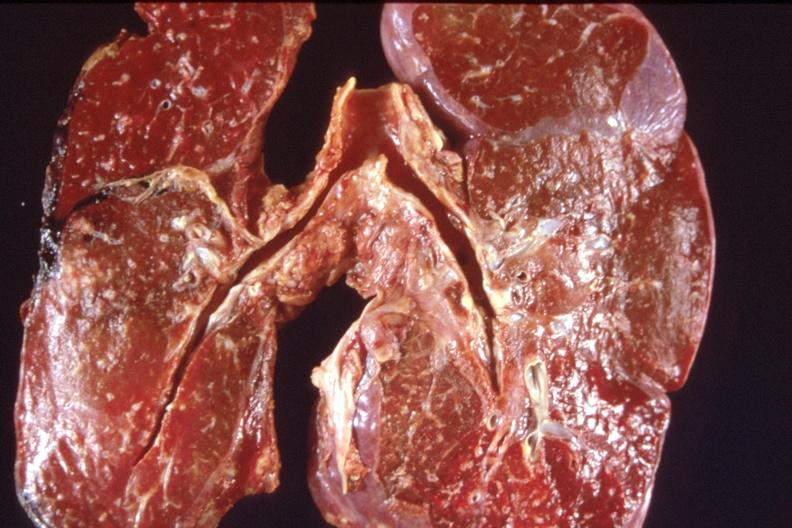s respiratory present?
Answer the question using a single word or phrase. Yes 